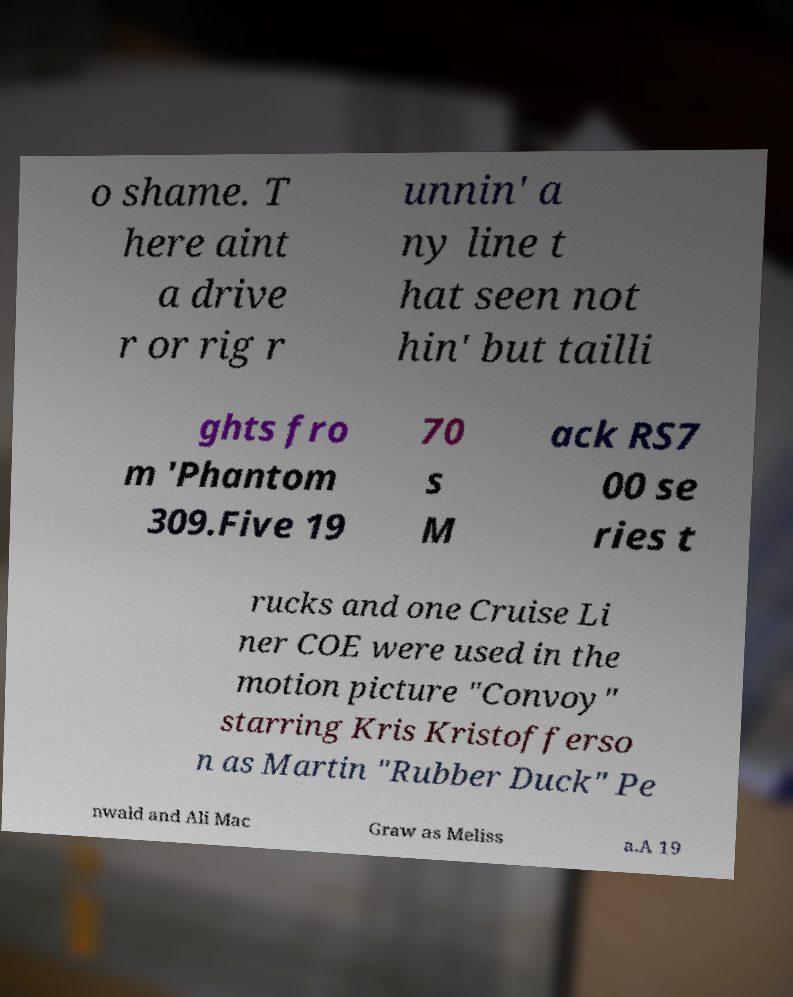Please read and relay the text visible in this image. What does it say? o shame. T here aint a drive r or rig r unnin' a ny line t hat seen not hin' but tailli ghts fro m 'Phantom 309.Five 19 70 s M ack RS7 00 se ries t rucks and one Cruise Li ner COE were used in the motion picture "Convoy" starring Kris Kristofferso n as Martin "Rubber Duck" Pe nwald and Ali Mac Graw as Meliss a.A 19 